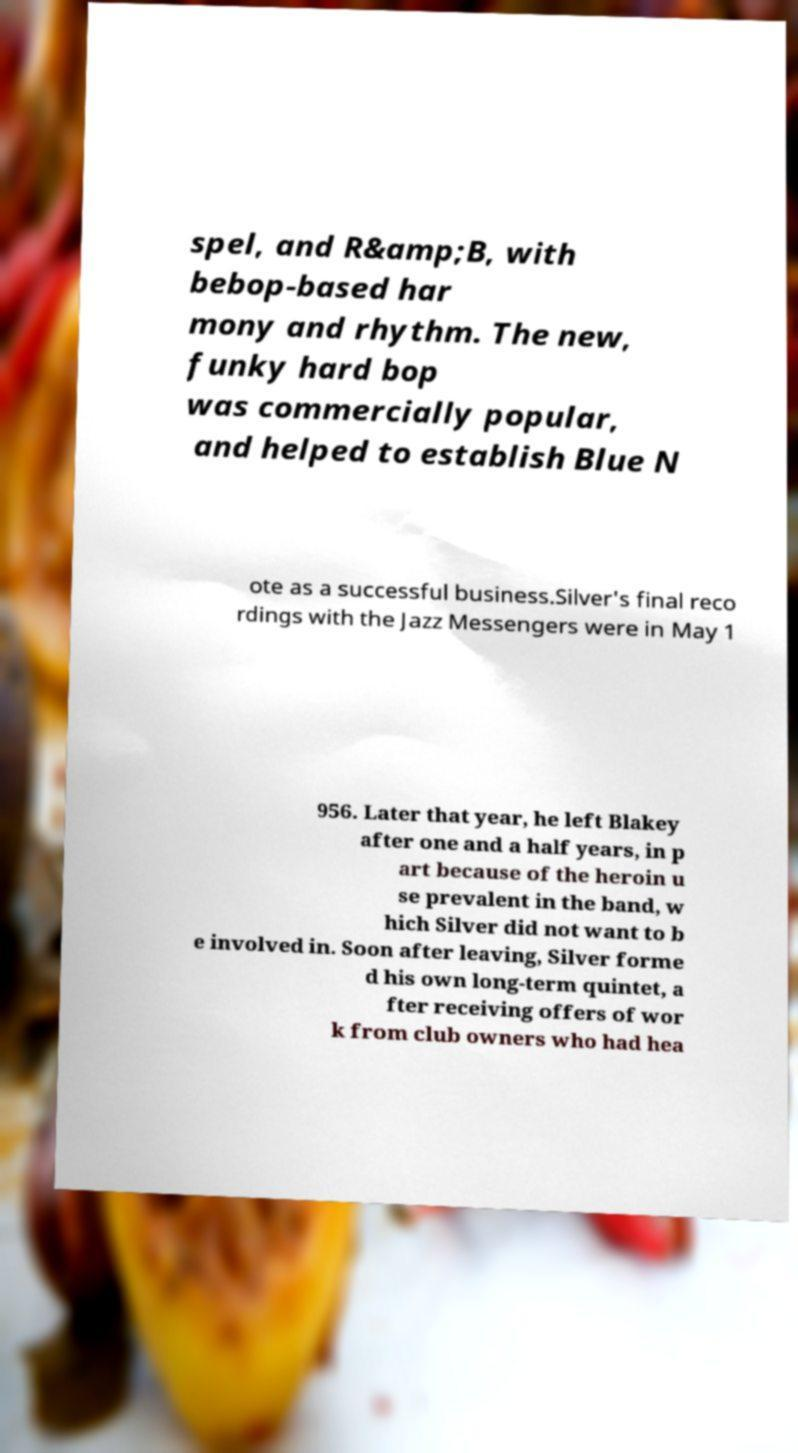Please read and relay the text visible in this image. What does it say? spel, and R&amp;B, with bebop-based har mony and rhythm. The new, funky hard bop was commercially popular, and helped to establish Blue N ote as a successful business.Silver's final reco rdings with the Jazz Messengers were in May 1 956. Later that year, he left Blakey after one and a half years, in p art because of the heroin u se prevalent in the band, w hich Silver did not want to b e involved in. Soon after leaving, Silver forme d his own long-term quintet, a fter receiving offers of wor k from club owners who had hea 